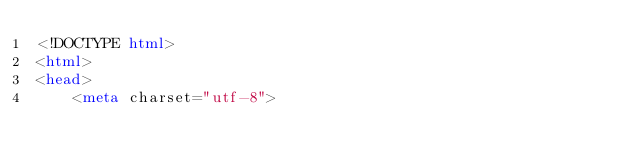Convert code to text. <code><loc_0><loc_0><loc_500><loc_500><_HTML_><!DOCTYPE html>
<html>
<head>
    <meta charset="utf-8"></code> 